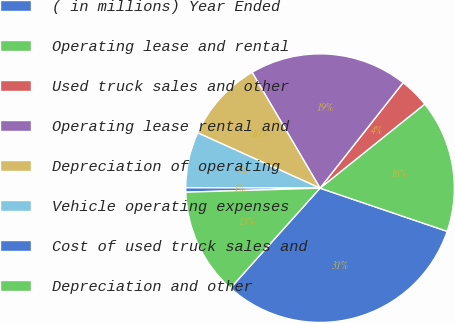Convert chart to OTSL. <chart><loc_0><loc_0><loc_500><loc_500><pie_chart><fcel>( in millions) Year Ended<fcel>Operating lease and rental<fcel>Used truck sales and other<fcel>Operating lease rental and<fcel>Depreciation of operating<fcel>Vehicle operating expenses<fcel>Cost of used truck sales and<fcel>Depreciation and other<nl><fcel>31.42%<fcel>15.98%<fcel>3.62%<fcel>19.06%<fcel>9.8%<fcel>6.71%<fcel>0.53%<fcel>12.89%<nl></chart> 